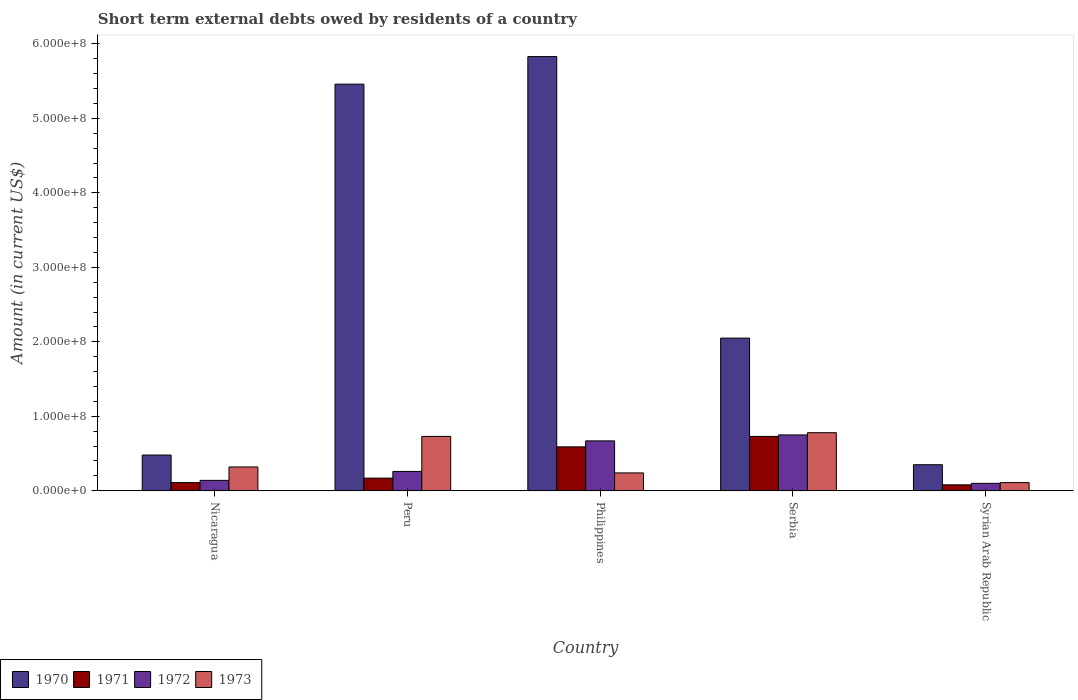How many different coloured bars are there?
Offer a very short reply. 4. How many bars are there on the 3rd tick from the right?
Keep it short and to the point. 4. What is the label of the 2nd group of bars from the left?
Ensure brevity in your answer.  Peru. In how many cases, is the number of bars for a given country not equal to the number of legend labels?
Give a very brief answer. 0. What is the amount of short-term external debts owed by residents in 1970 in Serbia?
Provide a succinct answer. 2.05e+08. Across all countries, what is the maximum amount of short-term external debts owed by residents in 1972?
Your answer should be compact. 7.50e+07. Across all countries, what is the minimum amount of short-term external debts owed by residents in 1970?
Provide a short and direct response. 3.50e+07. In which country was the amount of short-term external debts owed by residents in 1972 maximum?
Keep it short and to the point. Serbia. In which country was the amount of short-term external debts owed by residents in 1973 minimum?
Ensure brevity in your answer.  Syrian Arab Republic. What is the total amount of short-term external debts owed by residents in 1971 in the graph?
Provide a succinct answer. 1.68e+08. What is the difference between the amount of short-term external debts owed by residents in 1970 in Philippines and that in Serbia?
Your response must be concise. 3.78e+08. What is the difference between the amount of short-term external debts owed by residents in 1972 in Philippines and the amount of short-term external debts owed by residents in 1971 in Nicaragua?
Your response must be concise. 5.60e+07. What is the average amount of short-term external debts owed by residents in 1972 per country?
Keep it short and to the point. 3.84e+07. What is the difference between the amount of short-term external debts owed by residents of/in 1971 and amount of short-term external debts owed by residents of/in 1973 in Philippines?
Your response must be concise. 3.50e+07. In how many countries, is the amount of short-term external debts owed by residents in 1973 greater than 480000000 US$?
Give a very brief answer. 0. What is the ratio of the amount of short-term external debts owed by residents in 1972 in Nicaragua to that in Philippines?
Your answer should be very brief. 0.21. Is the amount of short-term external debts owed by residents in 1973 in Peru less than that in Syrian Arab Republic?
Keep it short and to the point. No. Is the difference between the amount of short-term external debts owed by residents in 1971 in Nicaragua and Serbia greater than the difference between the amount of short-term external debts owed by residents in 1973 in Nicaragua and Serbia?
Make the answer very short. No. What is the difference between the highest and the second highest amount of short-term external debts owed by residents in 1970?
Make the answer very short. 3.78e+08. What is the difference between the highest and the lowest amount of short-term external debts owed by residents in 1970?
Offer a very short reply. 5.48e+08. In how many countries, is the amount of short-term external debts owed by residents in 1972 greater than the average amount of short-term external debts owed by residents in 1972 taken over all countries?
Your response must be concise. 2. Is the sum of the amount of short-term external debts owed by residents in 1971 in Philippines and Serbia greater than the maximum amount of short-term external debts owed by residents in 1972 across all countries?
Your answer should be very brief. Yes. Is it the case that in every country, the sum of the amount of short-term external debts owed by residents in 1971 and amount of short-term external debts owed by residents in 1970 is greater than the sum of amount of short-term external debts owed by residents in 1972 and amount of short-term external debts owed by residents in 1973?
Make the answer very short. No. What does the 3rd bar from the right in Syrian Arab Republic represents?
Keep it short and to the point. 1971. How many bars are there?
Provide a short and direct response. 20. Are all the bars in the graph horizontal?
Give a very brief answer. No. Does the graph contain any zero values?
Provide a succinct answer. No. Does the graph contain grids?
Your response must be concise. No. Where does the legend appear in the graph?
Keep it short and to the point. Bottom left. What is the title of the graph?
Make the answer very short. Short term external debts owed by residents of a country. What is the label or title of the Y-axis?
Your answer should be compact. Amount (in current US$). What is the Amount (in current US$) of 1970 in Nicaragua?
Ensure brevity in your answer.  4.80e+07. What is the Amount (in current US$) in 1971 in Nicaragua?
Keep it short and to the point. 1.10e+07. What is the Amount (in current US$) in 1972 in Nicaragua?
Provide a succinct answer. 1.40e+07. What is the Amount (in current US$) of 1973 in Nicaragua?
Give a very brief answer. 3.20e+07. What is the Amount (in current US$) in 1970 in Peru?
Your answer should be very brief. 5.46e+08. What is the Amount (in current US$) of 1971 in Peru?
Ensure brevity in your answer.  1.70e+07. What is the Amount (in current US$) in 1972 in Peru?
Keep it short and to the point. 2.60e+07. What is the Amount (in current US$) in 1973 in Peru?
Your answer should be very brief. 7.30e+07. What is the Amount (in current US$) in 1970 in Philippines?
Keep it short and to the point. 5.83e+08. What is the Amount (in current US$) in 1971 in Philippines?
Keep it short and to the point. 5.90e+07. What is the Amount (in current US$) in 1972 in Philippines?
Give a very brief answer. 6.70e+07. What is the Amount (in current US$) of 1973 in Philippines?
Provide a succinct answer. 2.40e+07. What is the Amount (in current US$) of 1970 in Serbia?
Provide a short and direct response. 2.05e+08. What is the Amount (in current US$) of 1971 in Serbia?
Make the answer very short. 7.30e+07. What is the Amount (in current US$) in 1972 in Serbia?
Your answer should be very brief. 7.50e+07. What is the Amount (in current US$) in 1973 in Serbia?
Your answer should be compact. 7.80e+07. What is the Amount (in current US$) in 1970 in Syrian Arab Republic?
Your response must be concise. 3.50e+07. What is the Amount (in current US$) in 1972 in Syrian Arab Republic?
Make the answer very short. 1.00e+07. What is the Amount (in current US$) in 1973 in Syrian Arab Republic?
Your response must be concise. 1.10e+07. Across all countries, what is the maximum Amount (in current US$) in 1970?
Keep it short and to the point. 5.83e+08. Across all countries, what is the maximum Amount (in current US$) in 1971?
Provide a succinct answer. 7.30e+07. Across all countries, what is the maximum Amount (in current US$) in 1972?
Offer a very short reply. 7.50e+07. Across all countries, what is the maximum Amount (in current US$) in 1973?
Your answer should be compact. 7.80e+07. Across all countries, what is the minimum Amount (in current US$) in 1970?
Ensure brevity in your answer.  3.50e+07. Across all countries, what is the minimum Amount (in current US$) of 1971?
Provide a succinct answer. 8.00e+06. Across all countries, what is the minimum Amount (in current US$) in 1972?
Ensure brevity in your answer.  1.00e+07. Across all countries, what is the minimum Amount (in current US$) of 1973?
Make the answer very short. 1.10e+07. What is the total Amount (in current US$) in 1970 in the graph?
Give a very brief answer. 1.42e+09. What is the total Amount (in current US$) in 1971 in the graph?
Make the answer very short. 1.68e+08. What is the total Amount (in current US$) of 1972 in the graph?
Keep it short and to the point. 1.92e+08. What is the total Amount (in current US$) of 1973 in the graph?
Your answer should be very brief. 2.18e+08. What is the difference between the Amount (in current US$) of 1970 in Nicaragua and that in Peru?
Ensure brevity in your answer.  -4.98e+08. What is the difference between the Amount (in current US$) in 1971 in Nicaragua and that in Peru?
Ensure brevity in your answer.  -6.00e+06. What is the difference between the Amount (in current US$) of 1972 in Nicaragua and that in Peru?
Ensure brevity in your answer.  -1.20e+07. What is the difference between the Amount (in current US$) of 1973 in Nicaragua and that in Peru?
Offer a terse response. -4.10e+07. What is the difference between the Amount (in current US$) of 1970 in Nicaragua and that in Philippines?
Your response must be concise. -5.35e+08. What is the difference between the Amount (in current US$) of 1971 in Nicaragua and that in Philippines?
Offer a very short reply. -4.80e+07. What is the difference between the Amount (in current US$) in 1972 in Nicaragua and that in Philippines?
Offer a very short reply. -5.30e+07. What is the difference between the Amount (in current US$) in 1970 in Nicaragua and that in Serbia?
Provide a succinct answer. -1.57e+08. What is the difference between the Amount (in current US$) of 1971 in Nicaragua and that in Serbia?
Your response must be concise. -6.20e+07. What is the difference between the Amount (in current US$) in 1972 in Nicaragua and that in Serbia?
Your response must be concise. -6.10e+07. What is the difference between the Amount (in current US$) of 1973 in Nicaragua and that in Serbia?
Provide a succinct answer. -4.60e+07. What is the difference between the Amount (in current US$) of 1970 in Nicaragua and that in Syrian Arab Republic?
Provide a succinct answer. 1.30e+07. What is the difference between the Amount (in current US$) of 1971 in Nicaragua and that in Syrian Arab Republic?
Your answer should be compact. 3.00e+06. What is the difference between the Amount (in current US$) of 1972 in Nicaragua and that in Syrian Arab Republic?
Your answer should be compact. 4.00e+06. What is the difference between the Amount (in current US$) of 1973 in Nicaragua and that in Syrian Arab Republic?
Ensure brevity in your answer.  2.10e+07. What is the difference between the Amount (in current US$) of 1970 in Peru and that in Philippines?
Make the answer very short. -3.70e+07. What is the difference between the Amount (in current US$) in 1971 in Peru and that in Philippines?
Offer a very short reply. -4.20e+07. What is the difference between the Amount (in current US$) in 1972 in Peru and that in Philippines?
Your response must be concise. -4.10e+07. What is the difference between the Amount (in current US$) in 1973 in Peru and that in Philippines?
Offer a very short reply. 4.90e+07. What is the difference between the Amount (in current US$) in 1970 in Peru and that in Serbia?
Keep it short and to the point. 3.41e+08. What is the difference between the Amount (in current US$) of 1971 in Peru and that in Serbia?
Provide a succinct answer. -5.60e+07. What is the difference between the Amount (in current US$) in 1972 in Peru and that in Serbia?
Provide a succinct answer. -4.90e+07. What is the difference between the Amount (in current US$) in 1973 in Peru and that in Serbia?
Your response must be concise. -5.00e+06. What is the difference between the Amount (in current US$) of 1970 in Peru and that in Syrian Arab Republic?
Offer a very short reply. 5.11e+08. What is the difference between the Amount (in current US$) of 1971 in Peru and that in Syrian Arab Republic?
Provide a succinct answer. 9.00e+06. What is the difference between the Amount (in current US$) in 1972 in Peru and that in Syrian Arab Republic?
Keep it short and to the point. 1.60e+07. What is the difference between the Amount (in current US$) of 1973 in Peru and that in Syrian Arab Republic?
Your answer should be compact. 6.20e+07. What is the difference between the Amount (in current US$) in 1970 in Philippines and that in Serbia?
Your answer should be compact. 3.78e+08. What is the difference between the Amount (in current US$) of 1971 in Philippines and that in Serbia?
Your answer should be very brief. -1.40e+07. What is the difference between the Amount (in current US$) of 1972 in Philippines and that in Serbia?
Your answer should be compact. -8.00e+06. What is the difference between the Amount (in current US$) in 1973 in Philippines and that in Serbia?
Your answer should be very brief. -5.40e+07. What is the difference between the Amount (in current US$) of 1970 in Philippines and that in Syrian Arab Republic?
Provide a short and direct response. 5.48e+08. What is the difference between the Amount (in current US$) of 1971 in Philippines and that in Syrian Arab Republic?
Ensure brevity in your answer.  5.10e+07. What is the difference between the Amount (in current US$) in 1972 in Philippines and that in Syrian Arab Republic?
Give a very brief answer. 5.70e+07. What is the difference between the Amount (in current US$) of 1973 in Philippines and that in Syrian Arab Republic?
Make the answer very short. 1.30e+07. What is the difference between the Amount (in current US$) of 1970 in Serbia and that in Syrian Arab Republic?
Give a very brief answer. 1.70e+08. What is the difference between the Amount (in current US$) in 1971 in Serbia and that in Syrian Arab Republic?
Make the answer very short. 6.50e+07. What is the difference between the Amount (in current US$) of 1972 in Serbia and that in Syrian Arab Republic?
Make the answer very short. 6.50e+07. What is the difference between the Amount (in current US$) in 1973 in Serbia and that in Syrian Arab Republic?
Your answer should be compact. 6.70e+07. What is the difference between the Amount (in current US$) in 1970 in Nicaragua and the Amount (in current US$) in 1971 in Peru?
Give a very brief answer. 3.10e+07. What is the difference between the Amount (in current US$) of 1970 in Nicaragua and the Amount (in current US$) of 1972 in Peru?
Ensure brevity in your answer.  2.20e+07. What is the difference between the Amount (in current US$) of 1970 in Nicaragua and the Amount (in current US$) of 1973 in Peru?
Your answer should be very brief. -2.50e+07. What is the difference between the Amount (in current US$) of 1971 in Nicaragua and the Amount (in current US$) of 1972 in Peru?
Your answer should be compact. -1.50e+07. What is the difference between the Amount (in current US$) of 1971 in Nicaragua and the Amount (in current US$) of 1973 in Peru?
Provide a succinct answer. -6.20e+07. What is the difference between the Amount (in current US$) in 1972 in Nicaragua and the Amount (in current US$) in 1973 in Peru?
Provide a succinct answer. -5.90e+07. What is the difference between the Amount (in current US$) in 1970 in Nicaragua and the Amount (in current US$) in 1971 in Philippines?
Provide a short and direct response. -1.10e+07. What is the difference between the Amount (in current US$) in 1970 in Nicaragua and the Amount (in current US$) in 1972 in Philippines?
Keep it short and to the point. -1.90e+07. What is the difference between the Amount (in current US$) of 1970 in Nicaragua and the Amount (in current US$) of 1973 in Philippines?
Provide a short and direct response. 2.40e+07. What is the difference between the Amount (in current US$) of 1971 in Nicaragua and the Amount (in current US$) of 1972 in Philippines?
Offer a very short reply. -5.60e+07. What is the difference between the Amount (in current US$) in 1971 in Nicaragua and the Amount (in current US$) in 1973 in Philippines?
Offer a terse response. -1.30e+07. What is the difference between the Amount (in current US$) in 1972 in Nicaragua and the Amount (in current US$) in 1973 in Philippines?
Provide a short and direct response. -1.00e+07. What is the difference between the Amount (in current US$) of 1970 in Nicaragua and the Amount (in current US$) of 1971 in Serbia?
Your response must be concise. -2.50e+07. What is the difference between the Amount (in current US$) in 1970 in Nicaragua and the Amount (in current US$) in 1972 in Serbia?
Ensure brevity in your answer.  -2.70e+07. What is the difference between the Amount (in current US$) of 1970 in Nicaragua and the Amount (in current US$) of 1973 in Serbia?
Provide a short and direct response. -3.00e+07. What is the difference between the Amount (in current US$) in 1971 in Nicaragua and the Amount (in current US$) in 1972 in Serbia?
Make the answer very short. -6.40e+07. What is the difference between the Amount (in current US$) of 1971 in Nicaragua and the Amount (in current US$) of 1973 in Serbia?
Your answer should be compact. -6.70e+07. What is the difference between the Amount (in current US$) in 1972 in Nicaragua and the Amount (in current US$) in 1973 in Serbia?
Provide a short and direct response. -6.40e+07. What is the difference between the Amount (in current US$) in 1970 in Nicaragua and the Amount (in current US$) in 1971 in Syrian Arab Republic?
Your answer should be very brief. 4.00e+07. What is the difference between the Amount (in current US$) of 1970 in Nicaragua and the Amount (in current US$) of 1972 in Syrian Arab Republic?
Ensure brevity in your answer.  3.80e+07. What is the difference between the Amount (in current US$) in 1970 in Nicaragua and the Amount (in current US$) in 1973 in Syrian Arab Republic?
Offer a very short reply. 3.70e+07. What is the difference between the Amount (in current US$) of 1971 in Nicaragua and the Amount (in current US$) of 1973 in Syrian Arab Republic?
Your response must be concise. 0. What is the difference between the Amount (in current US$) of 1970 in Peru and the Amount (in current US$) of 1971 in Philippines?
Make the answer very short. 4.87e+08. What is the difference between the Amount (in current US$) in 1970 in Peru and the Amount (in current US$) in 1972 in Philippines?
Your response must be concise. 4.79e+08. What is the difference between the Amount (in current US$) in 1970 in Peru and the Amount (in current US$) in 1973 in Philippines?
Make the answer very short. 5.22e+08. What is the difference between the Amount (in current US$) in 1971 in Peru and the Amount (in current US$) in 1972 in Philippines?
Offer a terse response. -5.00e+07. What is the difference between the Amount (in current US$) of 1971 in Peru and the Amount (in current US$) of 1973 in Philippines?
Provide a succinct answer. -7.00e+06. What is the difference between the Amount (in current US$) of 1970 in Peru and the Amount (in current US$) of 1971 in Serbia?
Keep it short and to the point. 4.73e+08. What is the difference between the Amount (in current US$) of 1970 in Peru and the Amount (in current US$) of 1972 in Serbia?
Offer a very short reply. 4.71e+08. What is the difference between the Amount (in current US$) of 1970 in Peru and the Amount (in current US$) of 1973 in Serbia?
Make the answer very short. 4.68e+08. What is the difference between the Amount (in current US$) in 1971 in Peru and the Amount (in current US$) in 1972 in Serbia?
Offer a terse response. -5.80e+07. What is the difference between the Amount (in current US$) in 1971 in Peru and the Amount (in current US$) in 1973 in Serbia?
Provide a short and direct response. -6.10e+07. What is the difference between the Amount (in current US$) of 1972 in Peru and the Amount (in current US$) of 1973 in Serbia?
Provide a succinct answer. -5.20e+07. What is the difference between the Amount (in current US$) in 1970 in Peru and the Amount (in current US$) in 1971 in Syrian Arab Republic?
Offer a terse response. 5.38e+08. What is the difference between the Amount (in current US$) of 1970 in Peru and the Amount (in current US$) of 1972 in Syrian Arab Republic?
Your response must be concise. 5.36e+08. What is the difference between the Amount (in current US$) of 1970 in Peru and the Amount (in current US$) of 1973 in Syrian Arab Republic?
Provide a short and direct response. 5.35e+08. What is the difference between the Amount (in current US$) of 1971 in Peru and the Amount (in current US$) of 1972 in Syrian Arab Republic?
Provide a succinct answer. 7.00e+06. What is the difference between the Amount (in current US$) of 1971 in Peru and the Amount (in current US$) of 1973 in Syrian Arab Republic?
Give a very brief answer. 6.00e+06. What is the difference between the Amount (in current US$) of 1972 in Peru and the Amount (in current US$) of 1973 in Syrian Arab Republic?
Provide a succinct answer. 1.50e+07. What is the difference between the Amount (in current US$) of 1970 in Philippines and the Amount (in current US$) of 1971 in Serbia?
Offer a terse response. 5.10e+08. What is the difference between the Amount (in current US$) of 1970 in Philippines and the Amount (in current US$) of 1972 in Serbia?
Ensure brevity in your answer.  5.08e+08. What is the difference between the Amount (in current US$) of 1970 in Philippines and the Amount (in current US$) of 1973 in Serbia?
Give a very brief answer. 5.05e+08. What is the difference between the Amount (in current US$) in 1971 in Philippines and the Amount (in current US$) in 1972 in Serbia?
Offer a terse response. -1.60e+07. What is the difference between the Amount (in current US$) in 1971 in Philippines and the Amount (in current US$) in 1973 in Serbia?
Your response must be concise. -1.90e+07. What is the difference between the Amount (in current US$) of 1972 in Philippines and the Amount (in current US$) of 1973 in Serbia?
Provide a succinct answer. -1.10e+07. What is the difference between the Amount (in current US$) of 1970 in Philippines and the Amount (in current US$) of 1971 in Syrian Arab Republic?
Give a very brief answer. 5.75e+08. What is the difference between the Amount (in current US$) of 1970 in Philippines and the Amount (in current US$) of 1972 in Syrian Arab Republic?
Provide a succinct answer. 5.73e+08. What is the difference between the Amount (in current US$) in 1970 in Philippines and the Amount (in current US$) in 1973 in Syrian Arab Republic?
Your answer should be very brief. 5.72e+08. What is the difference between the Amount (in current US$) in 1971 in Philippines and the Amount (in current US$) in 1972 in Syrian Arab Republic?
Provide a short and direct response. 4.90e+07. What is the difference between the Amount (in current US$) of 1971 in Philippines and the Amount (in current US$) of 1973 in Syrian Arab Republic?
Your response must be concise. 4.80e+07. What is the difference between the Amount (in current US$) in 1972 in Philippines and the Amount (in current US$) in 1973 in Syrian Arab Republic?
Give a very brief answer. 5.60e+07. What is the difference between the Amount (in current US$) of 1970 in Serbia and the Amount (in current US$) of 1971 in Syrian Arab Republic?
Ensure brevity in your answer.  1.97e+08. What is the difference between the Amount (in current US$) of 1970 in Serbia and the Amount (in current US$) of 1972 in Syrian Arab Republic?
Your answer should be compact. 1.95e+08. What is the difference between the Amount (in current US$) in 1970 in Serbia and the Amount (in current US$) in 1973 in Syrian Arab Republic?
Your answer should be compact. 1.94e+08. What is the difference between the Amount (in current US$) in 1971 in Serbia and the Amount (in current US$) in 1972 in Syrian Arab Republic?
Offer a terse response. 6.30e+07. What is the difference between the Amount (in current US$) of 1971 in Serbia and the Amount (in current US$) of 1973 in Syrian Arab Republic?
Your answer should be very brief. 6.20e+07. What is the difference between the Amount (in current US$) of 1972 in Serbia and the Amount (in current US$) of 1973 in Syrian Arab Republic?
Keep it short and to the point. 6.40e+07. What is the average Amount (in current US$) of 1970 per country?
Offer a very short reply. 2.83e+08. What is the average Amount (in current US$) of 1971 per country?
Provide a short and direct response. 3.36e+07. What is the average Amount (in current US$) of 1972 per country?
Keep it short and to the point. 3.84e+07. What is the average Amount (in current US$) in 1973 per country?
Provide a succinct answer. 4.36e+07. What is the difference between the Amount (in current US$) in 1970 and Amount (in current US$) in 1971 in Nicaragua?
Keep it short and to the point. 3.70e+07. What is the difference between the Amount (in current US$) of 1970 and Amount (in current US$) of 1972 in Nicaragua?
Your response must be concise. 3.40e+07. What is the difference between the Amount (in current US$) of 1970 and Amount (in current US$) of 1973 in Nicaragua?
Provide a short and direct response. 1.60e+07. What is the difference between the Amount (in current US$) of 1971 and Amount (in current US$) of 1972 in Nicaragua?
Give a very brief answer. -3.00e+06. What is the difference between the Amount (in current US$) in 1971 and Amount (in current US$) in 1973 in Nicaragua?
Make the answer very short. -2.10e+07. What is the difference between the Amount (in current US$) in 1972 and Amount (in current US$) in 1973 in Nicaragua?
Your answer should be very brief. -1.80e+07. What is the difference between the Amount (in current US$) of 1970 and Amount (in current US$) of 1971 in Peru?
Keep it short and to the point. 5.29e+08. What is the difference between the Amount (in current US$) of 1970 and Amount (in current US$) of 1972 in Peru?
Offer a terse response. 5.20e+08. What is the difference between the Amount (in current US$) of 1970 and Amount (in current US$) of 1973 in Peru?
Your response must be concise. 4.73e+08. What is the difference between the Amount (in current US$) of 1971 and Amount (in current US$) of 1972 in Peru?
Offer a very short reply. -9.00e+06. What is the difference between the Amount (in current US$) of 1971 and Amount (in current US$) of 1973 in Peru?
Your answer should be very brief. -5.60e+07. What is the difference between the Amount (in current US$) of 1972 and Amount (in current US$) of 1973 in Peru?
Make the answer very short. -4.70e+07. What is the difference between the Amount (in current US$) in 1970 and Amount (in current US$) in 1971 in Philippines?
Your response must be concise. 5.24e+08. What is the difference between the Amount (in current US$) in 1970 and Amount (in current US$) in 1972 in Philippines?
Provide a succinct answer. 5.16e+08. What is the difference between the Amount (in current US$) in 1970 and Amount (in current US$) in 1973 in Philippines?
Keep it short and to the point. 5.59e+08. What is the difference between the Amount (in current US$) in 1971 and Amount (in current US$) in 1972 in Philippines?
Give a very brief answer. -8.00e+06. What is the difference between the Amount (in current US$) in 1971 and Amount (in current US$) in 1973 in Philippines?
Your response must be concise. 3.50e+07. What is the difference between the Amount (in current US$) in 1972 and Amount (in current US$) in 1973 in Philippines?
Provide a succinct answer. 4.30e+07. What is the difference between the Amount (in current US$) in 1970 and Amount (in current US$) in 1971 in Serbia?
Your answer should be very brief. 1.32e+08. What is the difference between the Amount (in current US$) in 1970 and Amount (in current US$) in 1972 in Serbia?
Offer a very short reply. 1.30e+08. What is the difference between the Amount (in current US$) in 1970 and Amount (in current US$) in 1973 in Serbia?
Your answer should be very brief. 1.27e+08. What is the difference between the Amount (in current US$) of 1971 and Amount (in current US$) of 1972 in Serbia?
Your answer should be compact. -2.00e+06. What is the difference between the Amount (in current US$) in 1971 and Amount (in current US$) in 1973 in Serbia?
Your answer should be compact. -5.00e+06. What is the difference between the Amount (in current US$) of 1970 and Amount (in current US$) of 1971 in Syrian Arab Republic?
Your answer should be very brief. 2.70e+07. What is the difference between the Amount (in current US$) of 1970 and Amount (in current US$) of 1972 in Syrian Arab Republic?
Keep it short and to the point. 2.50e+07. What is the difference between the Amount (in current US$) in 1970 and Amount (in current US$) in 1973 in Syrian Arab Republic?
Give a very brief answer. 2.40e+07. What is the difference between the Amount (in current US$) in 1971 and Amount (in current US$) in 1972 in Syrian Arab Republic?
Provide a succinct answer. -2.00e+06. What is the ratio of the Amount (in current US$) in 1970 in Nicaragua to that in Peru?
Your answer should be very brief. 0.09. What is the ratio of the Amount (in current US$) in 1971 in Nicaragua to that in Peru?
Offer a very short reply. 0.65. What is the ratio of the Amount (in current US$) in 1972 in Nicaragua to that in Peru?
Give a very brief answer. 0.54. What is the ratio of the Amount (in current US$) in 1973 in Nicaragua to that in Peru?
Make the answer very short. 0.44. What is the ratio of the Amount (in current US$) of 1970 in Nicaragua to that in Philippines?
Provide a short and direct response. 0.08. What is the ratio of the Amount (in current US$) in 1971 in Nicaragua to that in Philippines?
Give a very brief answer. 0.19. What is the ratio of the Amount (in current US$) of 1972 in Nicaragua to that in Philippines?
Offer a very short reply. 0.21. What is the ratio of the Amount (in current US$) of 1973 in Nicaragua to that in Philippines?
Offer a very short reply. 1.33. What is the ratio of the Amount (in current US$) of 1970 in Nicaragua to that in Serbia?
Your answer should be very brief. 0.23. What is the ratio of the Amount (in current US$) of 1971 in Nicaragua to that in Serbia?
Offer a very short reply. 0.15. What is the ratio of the Amount (in current US$) in 1972 in Nicaragua to that in Serbia?
Offer a very short reply. 0.19. What is the ratio of the Amount (in current US$) in 1973 in Nicaragua to that in Serbia?
Your response must be concise. 0.41. What is the ratio of the Amount (in current US$) of 1970 in Nicaragua to that in Syrian Arab Republic?
Make the answer very short. 1.37. What is the ratio of the Amount (in current US$) of 1971 in Nicaragua to that in Syrian Arab Republic?
Your response must be concise. 1.38. What is the ratio of the Amount (in current US$) of 1973 in Nicaragua to that in Syrian Arab Republic?
Your response must be concise. 2.91. What is the ratio of the Amount (in current US$) in 1970 in Peru to that in Philippines?
Offer a very short reply. 0.94. What is the ratio of the Amount (in current US$) in 1971 in Peru to that in Philippines?
Provide a short and direct response. 0.29. What is the ratio of the Amount (in current US$) of 1972 in Peru to that in Philippines?
Keep it short and to the point. 0.39. What is the ratio of the Amount (in current US$) of 1973 in Peru to that in Philippines?
Provide a succinct answer. 3.04. What is the ratio of the Amount (in current US$) of 1970 in Peru to that in Serbia?
Your response must be concise. 2.66. What is the ratio of the Amount (in current US$) of 1971 in Peru to that in Serbia?
Keep it short and to the point. 0.23. What is the ratio of the Amount (in current US$) of 1972 in Peru to that in Serbia?
Provide a succinct answer. 0.35. What is the ratio of the Amount (in current US$) in 1973 in Peru to that in Serbia?
Ensure brevity in your answer.  0.94. What is the ratio of the Amount (in current US$) of 1970 in Peru to that in Syrian Arab Republic?
Provide a succinct answer. 15.6. What is the ratio of the Amount (in current US$) in 1971 in Peru to that in Syrian Arab Republic?
Your answer should be very brief. 2.12. What is the ratio of the Amount (in current US$) of 1972 in Peru to that in Syrian Arab Republic?
Make the answer very short. 2.6. What is the ratio of the Amount (in current US$) of 1973 in Peru to that in Syrian Arab Republic?
Make the answer very short. 6.64. What is the ratio of the Amount (in current US$) in 1970 in Philippines to that in Serbia?
Ensure brevity in your answer.  2.84. What is the ratio of the Amount (in current US$) in 1971 in Philippines to that in Serbia?
Provide a short and direct response. 0.81. What is the ratio of the Amount (in current US$) of 1972 in Philippines to that in Serbia?
Your response must be concise. 0.89. What is the ratio of the Amount (in current US$) in 1973 in Philippines to that in Serbia?
Provide a short and direct response. 0.31. What is the ratio of the Amount (in current US$) in 1970 in Philippines to that in Syrian Arab Republic?
Provide a succinct answer. 16.66. What is the ratio of the Amount (in current US$) of 1971 in Philippines to that in Syrian Arab Republic?
Keep it short and to the point. 7.38. What is the ratio of the Amount (in current US$) in 1973 in Philippines to that in Syrian Arab Republic?
Offer a terse response. 2.18. What is the ratio of the Amount (in current US$) in 1970 in Serbia to that in Syrian Arab Republic?
Keep it short and to the point. 5.86. What is the ratio of the Amount (in current US$) of 1971 in Serbia to that in Syrian Arab Republic?
Ensure brevity in your answer.  9.12. What is the ratio of the Amount (in current US$) in 1972 in Serbia to that in Syrian Arab Republic?
Give a very brief answer. 7.5. What is the ratio of the Amount (in current US$) in 1973 in Serbia to that in Syrian Arab Republic?
Provide a short and direct response. 7.09. What is the difference between the highest and the second highest Amount (in current US$) in 1970?
Your answer should be compact. 3.70e+07. What is the difference between the highest and the second highest Amount (in current US$) of 1971?
Offer a terse response. 1.40e+07. What is the difference between the highest and the lowest Amount (in current US$) in 1970?
Offer a terse response. 5.48e+08. What is the difference between the highest and the lowest Amount (in current US$) of 1971?
Provide a short and direct response. 6.50e+07. What is the difference between the highest and the lowest Amount (in current US$) in 1972?
Make the answer very short. 6.50e+07. What is the difference between the highest and the lowest Amount (in current US$) in 1973?
Your answer should be very brief. 6.70e+07. 